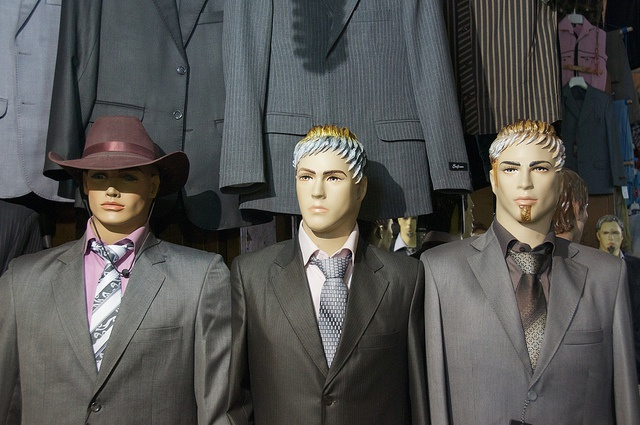Describe the objects in this image and their specific colors. I can see people in gray, black, and maroon tones, people in gray and black tones, tie in gray, black, and darkgray tones, tie in gray, lightgray, and darkgray tones, and tie in gray, darkgray, lightgray, and black tones in this image. 